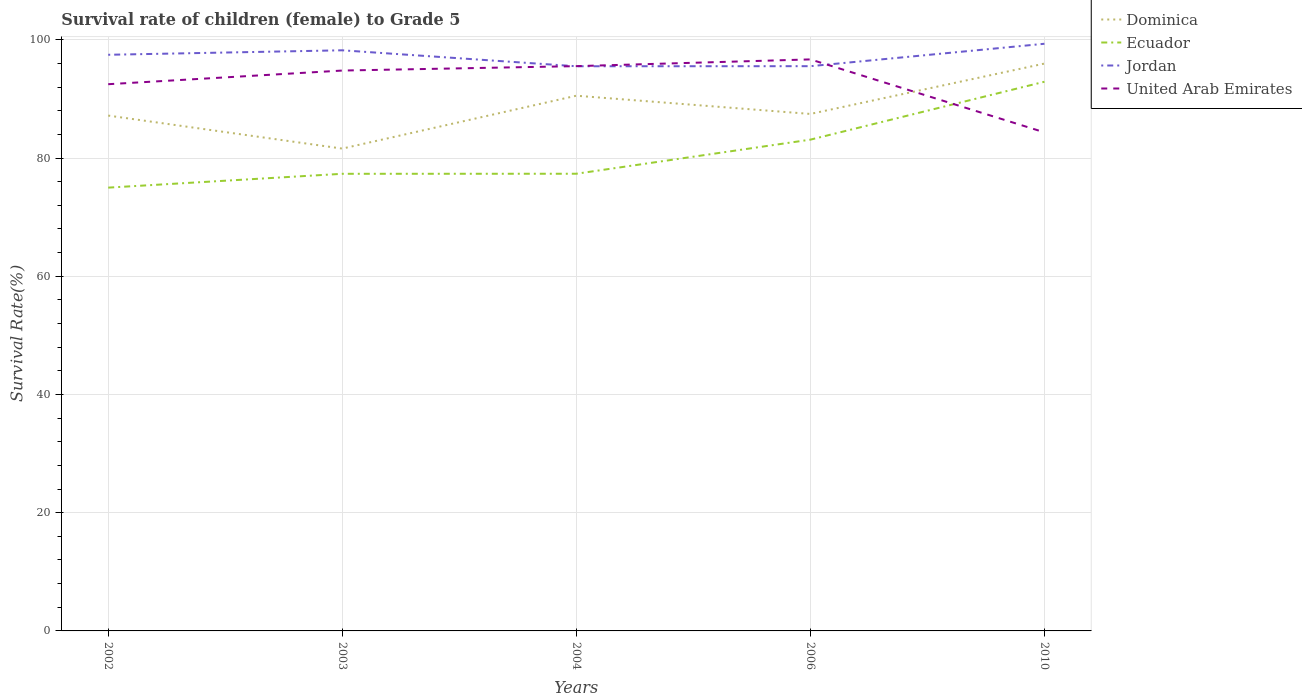How many different coloured lines are there?
Provide a short and direct response. 4. Is the number of lines equal to the number of legend labels?
Provide a short and direct response. Yes. Across all years, what is the maximum survival rate of female children to grade 5 in Jordan?
Make the answer very short. 95.52. In which year was the survival rate of female children to grade 5 in Jordan maximum?
Provide a short and direct response. 2004. What is the total survival rate of female children to grade 5 in Dominica in the graph?
Give a very brief answer. -8.52. What is the difference between the highest and the second highest survival rate of female children to grade 5 in Dominica?
Provide a succinct answer. 14.38. What is the difference between the highest and the lowest survival rate of female children to grade 5 in United Arab Emirates?
Offer a very short reply. 3. How many years are there in the graph?
Your answer should be very brief. 5. What is the difference between two consecutive major ticks on the Y-axis?
Offer a terse response. 20. Does the graph contain grids?
Provide a succinct answer. Yes. Where does the legend appear in the graph?
Provide a short and direct response. Top right. What is the title of the graph?
Provide a succinct answer. Survival rate of children (female) to Grade 5. Does "Turkey" appear as one of the legend labels in the graph?
Make the answer very short. No. What is the label or title of the Y-axis?
Offer a very short reply. Survival Rate(%). What is the Survival Rate(%) in Dominica in 2002?
Offer a very short reply. 87.18. What is the Survival Rate(%) of Ecuador in 2002?
Keep it short and to the point. 74.99. What is the Survival Rate(%) in Jordan in 2002?
Make the answer very short. 97.47. What is the Survival Rate(%) of United Arab Emirates in 2002?
Make the answer very short. 92.49. What is the Survival Rate(%) in Dominica in 2003?
Offer a terse response. 81.59. What is the Survival Rate(%) in Ecuador in 2003?
Your answer should be very brief. 77.33. What is the Survival Rate(%) in Jordan in 2003?
Offer a very short reply. 98.22. What is the Survival Rate(%) of United Arab Emirates in 2003?
Provide a succinct answer. 94.8. What is the Survival Rate(%) in Dominica in 2004?
Offer a very short reply. 90.54. What is the Survival Rate(%) in Ecuador in 2004?
Offer a very short reply. 77.34. What is the Survival Rate(%) of Jordan in 2004?
Ensure brevity in your answer.  95.52. What is the Survival Rate(%) in United Arab Emirates in 2004?
Your answer should be very brief. 95.54. What is the Survival Rate(%) in Dominica in 2006?
Your response must be concise. 87.46. What is the Survival Rate(%) of Ecuador in 2006?
Give a very brief answer. 83.11. What is the Survival Rate(%) in Jordan in 2006?
Provide a succinct answer. 95.53. What is the Survival Rate(%) in United Arab Emirates in 2006?
Your answer should be very brief. 96.68. What is the Survival Rate(%) of Dominica in 2010?
Ensure brevity in your answer.  95.98. What is the Survival Rate(%) in Ecuador in 2010?
Your response must be concise. 92.9. What is the Survival Rate(%) in Jordan in 2010?
Keep it short and to the point. 99.33. What is the Survival Rate(%) in United Arab Emirates in 2010?
Your response must be concise. 84.34. Across all years, what is the maximum Survival Rate(%) of Dominica?
Make the answer very short. 95.98. Across all years, what is the maximum Survival Rate(%) in Ecuador?
Offer a very short reply. 92.9. Across all years, what is the maximum Survival Rate(%) of Jordan?
Provide a succinct answer. 99.33. Across all years, what is the maximum Survival Rate(%) of United Arab Emirates?
Keep it short and to the point. 96.68. Across all years, what is the minimum Survival Rate(%) of Dominica?
Offer a very short reply. 81.59. Across all years, what is the minimum Survival Rate(%) in Ecuador?
Provide a short and direct response. 74.99. Across all years, what is the minimum Survival Rate(%) in Jordan?
Keep it short and to the point. 95.52. Across all years, what is the minimum Survival Rate(%) in United Arab Emirates?
Provide a short and direct response. 84.34. What is the total Survival Rate(%) in Dominica in the graph?
Ensure brevity in your answer.  442.74. What is the total Survival Rate(%) in Ecuador in the graph?
Ensure brevity in your answer.  405.67. What is the total Survival Rate(%) in Jordan in the graph?
Offer a very short reply. 486.07. What is the total Survival Rate(%) of United Arab Emirates in the graph?
Your answer should be very brief. 463.85. What is the difference between the Survival Rate(%) of Dominica in 2002 and that in 2003?
Offer a very short reply. 5.59. What is the difference between the Survival Rate(%) in Ecuador in 2002 and that in 2003?
Ensure brevity in your answer.  -2.34. What is the difference between the Survival Rate(%) in Jordan in 2002 and that in 2003?
Offer a very short reply. -0.76. What is the difference between the Survival Rate(%) of United Arab Emirates in 2002 and that in 2003?
Provide a short and direct response. -2.31. What is the difference between the Survival Rate(%) in Dominica in 2002 and that in 2004?
Give a very brief answer. -3.36. What is the difference between the Survival Rate(%) of Ecuador in 2002 and that in 2004?
Provide a succinct answer. -2.35. What is the difference between the Survival Rate(%) of Jordan in 2002 and that in 2004?
Make the answer very short. 1.94. What is the difference between the Survival Rate(%) in United Arab Emirates in 2002 and that in 2004?
Offer a terse response. -3.06. What is the difference between the Survival Rate(%) in Dominica in 2002 and that in 2006?
Your answer should be very brief. -0.28. What is the difference between the Survival Rate(%) in Ecuador in 2002 and that in 2006?
Offer a terse response. -8.12. What is the difference between the Survival Rate(%) of Jordan in 2002 and that in 2006?
Keep it short and to the point. 1.93. What is the difference between the Survival Rate(%) in United Arab Emirates in 2002 and that in 2006?
Your answer should be compact. -4.19. What is the difference between the Survival Rate(%) in Dominica in 2002 and that in 2010?
Keep it short and to the point. -8.8. What is the difference between the Survival Rate(%) of Ecuador in 2002 and that in 2010?
Ensure brevity in your answer.  -17.91. What is the difference between the Survival Rate(%) in Jordan in 2002 and that in 2010?
Offer a terse response. -1.86. What is the difference between the Survival Rate(%) of United Arab Emirates in 2002 and that in 2010?
Your answer should be compact. 8.15. What is the difference between the Survival Rate(%) in Dominica in 2003 and that in 2004?
Offer a very short reply. -8.95. What is the difference between the Survival Rate(%) of Ecuador in 2003 and that in 2004?
Your response must be concise. -0.01. What is the difference between the Survival Rate(%) of Jordan in 2003 and that in 2004?
Provide a short and direct response. 2.7. What is the difference between the Survival Rate(%) in United Arab Emirates in 2003 and that in 2004?
Provide a short and direct response. -0.75. What is the difference between the Survival Rate(%) in Dominica in 2003 and that in 2006?
Provide a succinct answer. -5.86. What is the difference between the Survival Rate(%) of Ecuador in 2003 and that in 2006?
Provide a short and direct response. -5.78. What is the difference between the Survival Rate(%) in Jordan in 2003 and that in 2006?
Your answer should be very brief. 2.69. What is the difference between the Survival Rate(%) of United Arab Emirates in 2003 and that in 2006?
Provide a succinct answer. -1.89. What is the difference between the Survival Rate(%) of Dominica in 2003 and that in 2010?
Your answer should be compact. -14.38. What is the difference between the Survival Rate(%) of Ecuador in 2003 and that in 2010?
Offer a very short reply. -15.57. What is the difference between the Survival Rate(%) of Jordan in 2003 and that in 2010?
Provide a succinct answer. -1.1. What is the difference between the Survival Rate(%) of United Arab Emirates in 2003 and that in 2010?
Provide a succinct answer. 10.45. What is the difference between the Survival Rate(%) in Dominica in 2004 and that in 2006?
Give a very brief answer. 3.08. What is the difference between the Survival Rate(%) of Ecuador in 2004 and that in 2006?
Your answer should be very brief. -5.77. What is the difference between the Survival Rate(%) in Jordan in 2004 and that in 2006?
Keep it short and to the point. -0.01. What is the difference between the Survival Rate(%) in United Arab Emirates in 2004 and that in 2006?
Ensure brevity in your answer.  -1.14. What is the difference between the Survival Rate(%) in Dominica in 2004 and that in 2010?
Make the answer very short. -5.44. What is the difference between the Survival Rate(%) of Ecuador in 2004 and that in 2010?
Give a very brief answer. -15.56. What is the difference between the Survival Rate(%) in Jordan in 2004 and that in 2010?
Provide a short and direct response. -3.8. What is the difference between the Survival Rate(%) of United Arab Emirates in 2004 and that in 2010?
Provide a succinct answer. 11.2. What is the difference between the Survival Rate(%) of Dominica in 2006 and that in 2010?
Provide a succinct answer. -8.52. What is the difference between the Survival Rate(%) in Ecuador in 2006 and that in 2010?
Your answer should be compact. -9.8. What is the difference between the Survival Rate(%) of Jordan in 2006 and that in 2010?
Your answer should be very brief. -3.79. What is the difference between the Survival Rate(%) in United Arab Emirates in 2006 and that in 2010?
Provide a succinct answer. 12.34. What is the difference between the Survival Rate(%) of Dominica in 2002 and the Survival Rate(%) of Ecuador in 2003?
Your answer should be very brief. 9.85. What is the difference between the Survival Rate(%) in Dominica in 2002 and the Survival Rate(%) in Jordan in 2003?
Keep it short and to the point. -11.04. What is the difference between the Survival Rate(%) of Dominica in 2002 and the Survival Rate(%) of United Arab Emirates in 2003?
Provide a short and direct response. -7.62. What is the difference between the Survival Rate(%) of Ecuador in 2002 and the Survival Rate(%) of Jordan in 2003?
Give a very brief answer. -23.23. What is the difference between the Survival Rate(%) of Ecuador in 2002 and the Survival Rate(%) of United Arab Emirates in 2003?
Offer a terse response. -19.81. What is the difference between the Survival Rate(%) in Jordan in 2002 and the Survival Rate(%) in United Arab Emirates in 2003?
Keep it short and to the point. 2.67. What is the difference between the Survival Rate(%) in Dominica in 2002 and the Survival Rate(%) in Ecuador in 2004?
Offer a very short reply. 9.84. What is the difference between the Survival Rate(%) of Dominica in 2002 and the Survival Rate(%) of Jordan in 2004?
Ensure brevity in your answer.  -8.34. What is the difference between the Survival Rate(%) in Dominica in 2002 and the Survival Rate(%) in United Arab Emirates in 2004?
Your answer should be very brief. -8.36. What is the difference between the Survival Rate(%) in Ecuador in 2002 and the Survival Rate(%) in Jordan in 2004?
Offer a very short reply. -20.53. What is the difference between the Survival Rate(%) in Ecuador in 2002 and the Survival Rate(%) in United Arab Emirates in 2004?
Provide a short and direct response. -20.55. What is the difference between the Survival Rate(%) of Jordan in 2002 and the Survival Rate(%) of United Arab Emirates in 2004?
Ensure brevity in your answer.  1.92. What is the difference between the Survival Rate(%) in Dominica in 2002 and the Survival Rate(%) in Ecuador in 2006?
Offer a terse response. 4.07. What is the difference between the Survival Rate(%) in Dominica in 2002 and the Survival Rate(%) in Jordan in 2006?
Your answer should be very brief. -8.36. What is the difference between the Survival Rate(%) of Dominica in 2002 and the Survival Rate(%) of United Arab Emirates in 2006?
Offer a terse response. -9.5. What is the difference between the Survival Rate(%) of Ecuador in 2002 and the Survival Rate(%) of Jordan in 2006?
Your response must be concise. -20.54. What is the difference between the Survival Rate(%) of Ecuador in 2002 and the Survival Rate(%) of United Arab Emirates in 2006?
Offer a terse response. -21.69. What is the difference between the Survival Rate(%) in Jordan in 2002 and the Survival Rate(%) in United Arab Emirates in 2006?
Keep it short and to the point. 0.78. What is the difference between the Survival Rate(%) in Dominica in 2002 and the Survival Rate(%) in Ecuador in 2010?
Make the answer very short. -5.72. What is the difference between the Survival Rate(%) in Dominica in 2002 and the Survival Rate(%) in Jordan in 2010?
Offer a terse response. -12.15. What is the difference between the Survival Rate(%) of Dominica in 2002 and the Survival Rate(%) of United Arab Emirates in 2010?
Provide a succinct answer. 2.84. What is the difference between the Survival Rate(%) of Ecuador in 2002 and the Survival Rate(%) of Jordan in 2010?
Offer a terse response. -24.34. What is the difference between the Survival Rate(%) of Ecuador in 2002 and the Survival Rate(%) of United Arab Emirates in 2010?
Ensure brevity in your answer.  -9.35. What is the difference between the Survival Rate(%) of Jordan in 2002 and the Survival Rate(%) of United Arab Emirates in 2010?
Your response must be concise. 13.12. What is the difference between the Survival Rate(%) in Dominica in 2003 and the Survival Rate(%) in Ecuador in 2004?
Give a very brief answer. 4.25. What is the difference between the Survival Rate(%) of Dominica in 2003 and the Survival Rate(%) of Jordan in 2004?
Offer a terse response. -13.93. What is the difference between the Survival Rate(%) in Dominica in 2003 and the Survival Rate(%) in United Arab Emirates in 2004?
Your answer should be compact. -13.95. What is the difference between the Survival Rate(%) of Ecuador in 2003 and the Survival Rate(%) of Jordan in 2004?
Offer a terse response. -18.19. What is the difference between the Survival Rate(%) in Ecuador in 2003 and the Survival Rate(%) in United Arab Emirates in 2004?
Provide a short and direct response. -18.21. What is the difference between the Survival Rate(%) of Jordan in 2003 and the Survival Rate(%) of United Arab Emirates in 2004?
Your response must be concise. 2.68. What is the difference between the Survival Rate(%) in Dominica in 2003 and the Survival Rate(%) in Ecuador in 2006?
Keep it short and to the point. -1.51. What is the difference between the Survival Rate(%) in Dominica in 2003 and the Survival Rate(%) in Jordan in 2006?
Your answer should be compact. -13.94. What is the difference between the Survival Rate(%) of Dominica in 2003 and the Survival Rate(%) of United Arab Emirates in 2006?
Provide a succinct answer. -15.09. What is the difference between the Survival Rate(%) of Ecuador in 2003 and the Survival Rate(%) of Jordan in 2006?
Offer a terse response. -18.2. What is the difference between the Survival Rate(%) in Ecuador in 2003 and the Survival Rate(%) in United Arab Emirates in 2006?
Keep it short and to the point. -19.35. What is the difference between the Survival Rate(%) in Jordan in 2003 and the Survival Rate(%) in United Arab Emirates in 2006?
Your answer should be compact. 1.54. What is the difference between the Survival Rate(%) in Dominica in 2003 and the Survival Rate(%) in Ecuador in 2010?
Keep it short and to the point. -11.31. What is the difference between the Survival Rate(%) in Dominica in 2003 and the Survival Rate(%) in Jordan in 2010?
Give a very brief answer. -17.73. What is the difference between the Survival Rate(%) of Dominica in 2003 and the Survival Rate(%) of United Arab Emirates in 2010?
Offer a very short reply. -2.75. What is the difference between the Survival Rate(%) of Ecuador in 2003 and the Survival Rate(%) of Jordan in 2010?
Ensure brevity in your answer.  -22. What is the difference between the Survival Rate(%) in Ecuador in 2003 and the Survival Rate(%) in United Arab Emirates in 2010?
Keep it short and to the point. -7.01. What is the difference between the Survival Rate(%) of Jordan in 2003 and the Survival Rate(%) of United Arab Emirates in 2010?
Ensure brevity in your answer.  13.88. What is the difference between the Survival Rate(%) of Dominica in 2004 and the Survival Rate(%) of Ecuador in 2006?
Your answer should be compact. 7.43. What is the difference between the Survival Rate(%) in Dominica in 2004 and the Survival Rate(%) in Jordan in 2006?
Your answer should be compact. -5. What is the difference between the Survival Rate(%) in Dominica in 2004 and the Survival Rate(%) in United Arab Emirates in 2006?
Your answer should be compact. -6.14. What is the difference between the Survival Rate(%) of Ecuador in 2004 and the Survival Rate(%) of Jordan in 2006?
Your answer should be very brief. -18.19. What is the difference between the Survival Rate(%) in Ecuador in 2004 and the Survival Rate(%) in United Arab Emirates in 2006?
Keep it short and to the point. -19.34. What is the difference between the Survival Rate(%) of Jordan in 2004 and the Survival Rate(%) of United Arab Emirates in 2006?
Your response must be concise. -1.16. What is the difference between the Survival Rate(%) in Dominica in 2004 and the Survival Rate(%) in Ecuador in 2010?
Your response must be concise. -2.36. What is the difference between the Survival Rate(%) in Dominica in 2004 and the Survival Rate(%) in Jordan in 2010?
Provide a succinct answer. -8.79. What is the difference between the Survival Rate(%) of Dominica in 2004 and the Survival Rate(%) of United Arab Emirates in 2010?
Your answer should be compact. 6.2. What is the difference between the Survival Rate(%) in Ecuador in 2004 and the Survival Rate(%) in Jordan in 2010?
Offer a very short reply. -21.99. What is the difference between the Survival Rate(%) of Ecuador in 2004 and the Survival Rate(%) of United Arab Emirates in 2010?
Keep it short and to the point. -7. What is the difference between the Survival Rate(%) of Jordan in 2004 and the Survival Rate(%) of United Arab Emirates in 2010?
Provide a short and direct response. 11.18. What is the difference between the Survival Rate(%) of Dominica in 2006 and the Survival Rate(%) of Ecuador in 2010?
Offer a very short reply. -5.45. What is the difference between the Survival Rate(%) in Dominica in 2006 and the Survival Rate(%) in Jordan in 2010?
Offer a terse response. -11.87. What is the difference between the Survival Rate(%) of Dominica in 2006 and the Survival Rate(%) of United Arab Emirates in 2010?
Your answer should be very brief. 3.11. What is the difference between the Survival Rate(%) of Ecuador in 2006 and the Survival Rate(%) of Jordan in 2010?
Ensure brevity in your answer.  -16.22. What is the difference between the Survival Rate(%) of Ecuador in 2006 and the Survival Rate(%) of United Arab Emirates in 2010?
Keep it short and to the point. -1.24. What is the difference between the Survival Rate(%) of Jordan in 2006 and the Survival Rate(%) of United Arab Emirates in 2010?
Offer a very short reply. 11.19. What is the average Survival Rate(%) of Dominica per year?
Make the answer very short. 88.55. What is the average Survival Rate(%) in Ecuador per year?
Give a very brief answer. 81.13. What is the average Survival Rate(%) of Jordan per year?
Make the answer very short. 97.21. What is the average Survival Rate(%) of United Arab Emirates per year?
Provide a short and direct response. 92.77. In the year 2002, what is the difference between the Survival Rate(%) of Dominica and Survival Rate(%) of Ecuador?
Offer a terse response. 12.19. In the year 2002, what is the difference between the Survival Rate(%) in Dominica and Survival Rate(%) in Jordan?
Your answer should be very brief. -10.29. In the year 2002, what is the difference between the Survival Rate(%) in Dominica and Survival Rate(%) in United Arab Emirates?
Your answer should be very brief. -5.31. In the year 2002, what is the difference between the Survival Rate(%) of Ecuador and Survival Rate(%) of Jordan?
Provide a short and direct response. -22.47. In the year 2002, what is the difference between the Survival Rate(%) in Ecuador and Survival Rate(%) in United Arab Emirates?
Offer a very short reply. -17.5. In the year 2002, what is the difference between the Survival Rate(%) in Jordan and Survival Rate(%) in United Arab Emirates?
Offer a terse response. 4.98. In the year 2003, what is the difference between the Survival Rate(%) of Dominica and Survival Rate(%) of Ecuador?
Your answer should be compact. 4.26. In the year 2003, what is the difference between the Survival Rate(%) of Dominica and Survival Rate(%) of Jordan?
Ensure brevity in your answer.  -16.63. In the year 2003, what is the difference between the Survival Rate(%) of Dominica and Survival Rate(%) of United Arab Emirates?
Provide a succinct answer. -13.2. In the year 2003, what is the difference between the Survival Rate(%) of Ecuador and Survival Rate(%) of Jordan?
Offer a very short reply. -20.89. In the year 2003, what is the difference between the Survival Rate(%) of Ecuador and Survival Rate(%) of United Arab Emirates?
Provide a succinct answer. -17.47. In the year 2003, what is the difference between the Survival Rate(%) of Jordan and Survival Rate(%) of United Arab Emirates?
Your answer should be very brief. 3.43. In the year 2004, what is the difference between the Survival Rate(%) of Dominica and Survival Rate(%) of Ecuador?
Offer a very short reply. 13.2. In the year 2004, what is the difference between the Survival Rate(%) of Dominica and Survival Rate(%) of Jordan?
Ensure brevity in your answer.  -4.98. In the year 2004, what is the difference between the Survival Rate(%) of Dominica and Survival Rate(%) of United Arab Emirates?
Keep it short and to the point. -5. In the year 2004, what is the difference between the Survival Rate(%) in Ecuador and Survival Rate(%) in Jordan?
Give a very brief answer. -18.18. In the year 2004, what is the difference between the Survival Rate(%) in Ecuador and Survival Rate(%) in United Arab Emirates?
Keep it short and to the point. -18.2. In the year 2004, what is the difference between the Survival Rate(%) in Jordan and Survival Rate(%) in United Arab Emirates?
Offer a terse response. -0.02. In the year 2006, what is the difference between the Survival Rate(%) in Dominica and Survival Rate(%) in Ecuador?
Make the answer very short. 4.35. In the year 2006, what is the difference between the Survival Rate(%) of Dominica and Survival Rate(%) of Jordan?
Make the answer very short. -8.08. In the year 2006, what is the difference between the Survival Rate(%) in Dominica and Survival Rate(%) in United Arab Emirates?
Offer a terse response. -9.23. In the year 2006, what is the difference between the Survival Rate(%) in Ecuador and Survival Rate(%) in Jordan?
Give a very brief answer. -12.43. In the year 2006, what is the difference between the Survival Rate(%) of Ecuador and Survival Rate(%) of United Arab Emirates?
Ensure brevity in your answer.  -13.57. In the year 2006, what is the difference between the Survival Rate(%) of Jordan and Survival Rate(%) of United Arab Emirates?
Offer a terse response. -1.15. In the year 2010, what is the difference between the Survival Rate(%) of Dominica and Survival Rate(%) of Ecuador?
Offer a very short reply. 3.07. In the year 2010, what is the difference between the Survival Rate(%) of Dominica and Survival Rate(%) of Jordan?
Keep it short and to the point. -3.35. In the year 2010, what is the difference between the Survival Rate(%) in Dominica and Survival Rate(%) in United Arab Emirates?
Your answer should be compact. 11.63. In the year 2010, what is the difference between the Survival Rate(%) of Ecuador and Survival Rate(%) of Jordan?
Ensure brevity in your answer.  -6.42. In the year 2010, what is the difference between the Survival Rate(%) in Ecuador and Survival Rate(%) in United Arab Emirates?
Offer a terse response. 8.56. In the year 2010, what is the difference between the Survival Rate(%) of Jordan and Survival Rate(%) of United Arab Emirates?
Give a very brief answer. 14.99. What is the ratio of the Survival Rate(%) of Dominica in 2002 to that in 2003?
Your answer should be very brief. 1.07. What is the ratio of the Survival Rate(%) in Ecuador in 2002 to that in 2003?
Provide a succinct answer. 0.97. What is the ratio of the Survival Rate(%) in United Arab Emirates in 2002 to that in 2003?
Give a very brief answer. 0.98. What is the ratio of the Survival Rate(%) of Dominica in 2002 to that in 2004?
Offer a very short reply. 0.96. What is the ratio of the Survival Rate(%) of Ecuador in 2002 to that in 2004?
Your response must be concise. 0.97. What is the ratio of the Survival Rate(%) of Jordan in 2002 to that in 2004?
Your answer should be compact. 1.02. What is the ratio of the Survival Rate(%) of Dominica in 2002 to that in 2006?
Provide a short and direct response. 1. What is the ratio of the Survival Rate(%) in Ecuador in 2002 to that in 2006?
Make the answer very short. 0.9. What is the ratio of the Survival Rate(%) in Jordan in 2002 to that in 2006?
Offer a very short reply. 1.02. What is the ratio of the Survival Rate(%) in United Arab Emirates in 2002 to that in 2006?
Your answer should be compact. 0.96. What is the ratio of the Survival Rate(%) in Dominica in 2002 to that in 2010?
Your answer should be compact. 0.91. What is the ratio of the Survival Rate(%) of Ecuador in 2002 to that in 2010?
Your response must be concise. 0.81. What is the ratio of the Survival Rate(%) in Jordan in 2002 to that in 2010?
Ensure brevity in your answer.  0.98. What is the ratio of the Survival Rate(%) in United Arab Emirates in 2002 to that in 2010?
Ensure brevity in your answer.  1.1. What is the ratio of the Survival Rate(%) of Dominica in 2003 to that in 2004?
Offer a terse response. 0.9. What is the ratio of the Survival Rate(%) in Jordan in 2003 to that in 2004?
Offer a very short reply. 1.03. What is the ratio of the Survival Rate(%) in Dominica in 2003 to that in 2006?
Offer a terse response. 0.93. What is the ratio of the Survival Rate(%) in Ecuador in 2003 to that in 2006?
Your response must be concise. 0.93. What is the ratio of the Survival Rate(%) of Jordan in 2003 to that in 2006?
Keep it short and to the point. 1.03. What is the ratio of the Survival Rate(%) of United Arab Emirates in 2003 to that in 2006?
Your answer should be compact. 0.98. What is the ratio of the Survival Rate(%) of Dominica in 2003 to that in 2010?
Your answer should be very brief. 0.85. What is the ratio of the Survival Rate(%) in Ecuador in 2003 to that in 2010?
Provide a succinct answer. 0.83. What is the ratio of the Survival Rate(%) in Jordan in 2003 to that in 2010?
Keep it short and to the point. 0.99. What is the ratio of the Survival Rate(%) of United Arab Emirates in 2003 to that in 2010?
Your response must be concise. 1.12. What is the ratio of the Survival Rate(%) in Dominica in 2004 to that in 2006?
Ensure brevity in your answer.  1.04. What is the ratio of the Survival Rate(%) of Ecuador in 2004 to that in 2006?
Provide a short and direct response. 0.93. What is the ratio of the Survival Rate(%) of Dominica in 2004 to that in 2010?
Keep it short and to the point. 0.94. What is the ratio of the Survival Rate(%) of Ecuador in 2004 to that in 2010?
Ensure brevity in your answer.  0.83. What is the ratio of the Survival Rate(%) of Jordan in 2004 to that in 2010?
Offer a very short reply. 0.96. What is the ratio of the Survival Rate(%) in United Arab Emirates in 2004 to that in 2010?
Make the answer very short. 1.13. What is the ratio of the Survival Rate(%) of Dominica in 2006 to that in 2010?
Provide a short and direct response. 0.91. What is the ratio of the Survival Rate(%) in Ecuador in 2006 to that in 2010?
Ensure brevity in your answer.  0.89. What is the ratio of the Survival Rate(%) in Jordan in 2006 to that in 2010?
Provide a short and direct response. 0.96. What is the ratio of the Survival Rate(%) in United Arab Emirates in 2006 to that in 2010?
Ensure brevity in your answer.  1.15. What is the difference between the highest and the second highest Survival Rate(%) of Dominica?
Your response must be concise. 5.44. What is the difference between the highest and the second highest Survival Rate(%) in Ecuador?
Your response must be concise. 9.8. What is the difference between the highest and the second highest Survival Rate(%) in Jordan?
Make the answer very short. 1.1. What is the difference between the highest and the second highest Survival Rate(%) of United Arab Emirates?
Provide a short and direct response. 1.14. What is the difference between the highest and the lowest Survival Rate(%) of Dominica?
Provide a short and direct response. 14.38. What is the difference between the highest and the lowest Survival Rate(%) in Ecuador?
Your answer should be very brief. 17.91. What is the difference between the highest and the lowest Survival Rate(%) in Jordan?
Ensure brevity in your answer.  3.8. What is the difference between the highest and the lowest Survival Rate(%) of United Arab Emirates?
Offer a terse response. 12.34. 